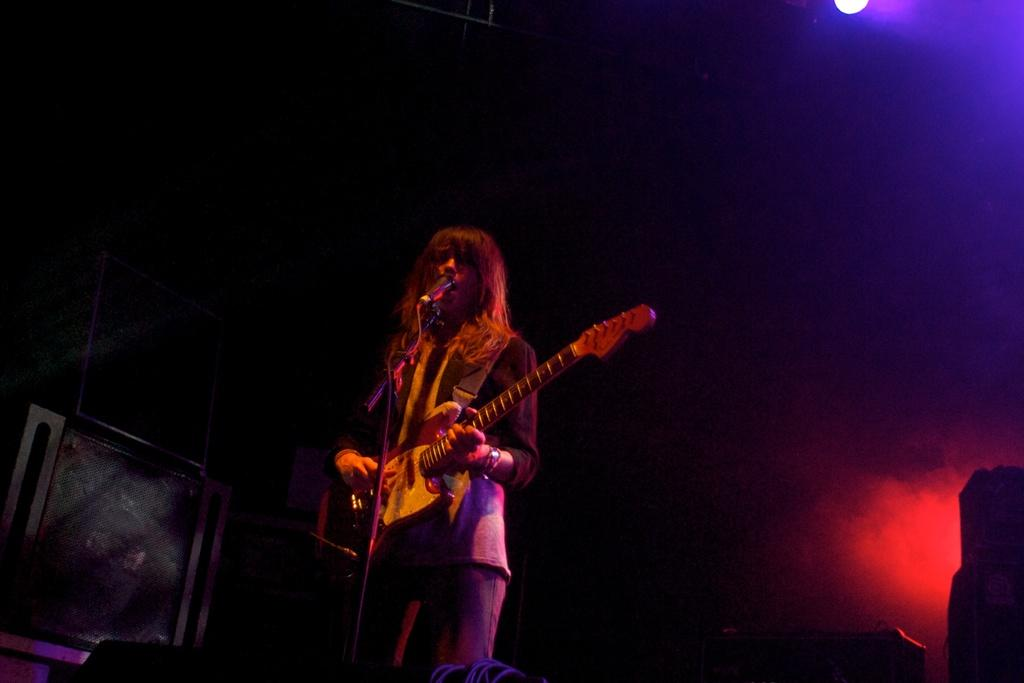Who is the main subject in the image? There is a woman in the image. What is the woman doing in the image? The woman is standing, playing a guitar, singing, and using a microphone. Can you describe the lighting in the image? There is a light visible in the image. What color is the knot tied on the bag in the image? There is no knot tied on a bag present in the image. 